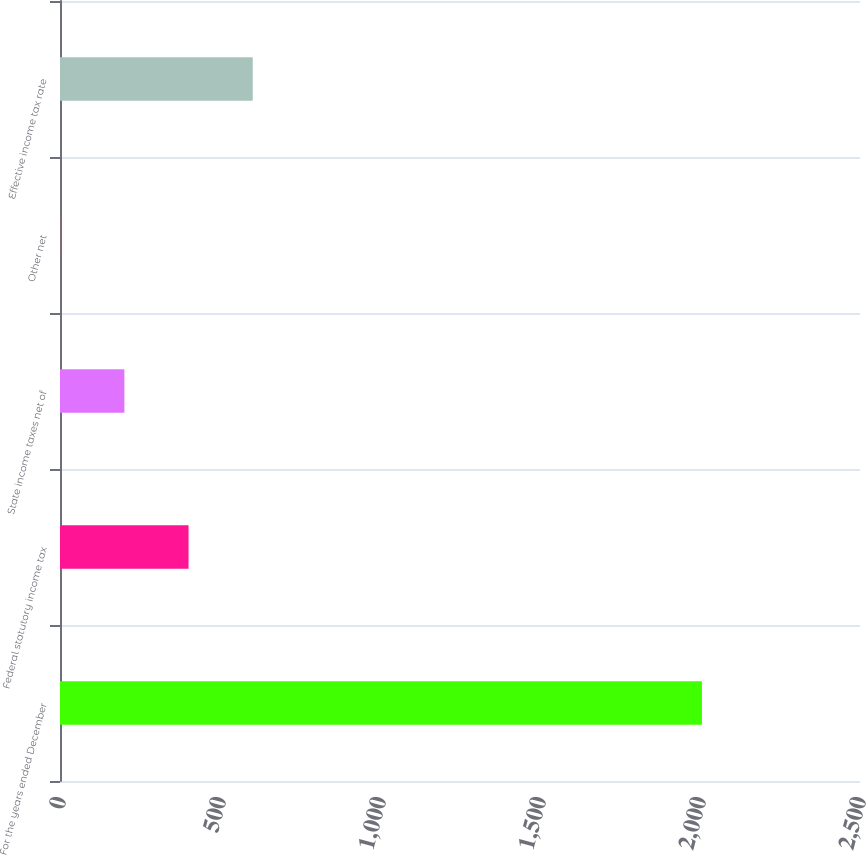<chart> <loc_0><loc_0><loc_500><loc_500><bar_chart><fcel>For the years ended December<fcel>Federal statutory income tax<fcel>State income taxes net of<fcel>Other net<fcel>Effective income tax rate<nl><fcel>2006<fcel>401.76<fcel>201.23<fcel>0.7<fcel>602.29<nl></chart> 